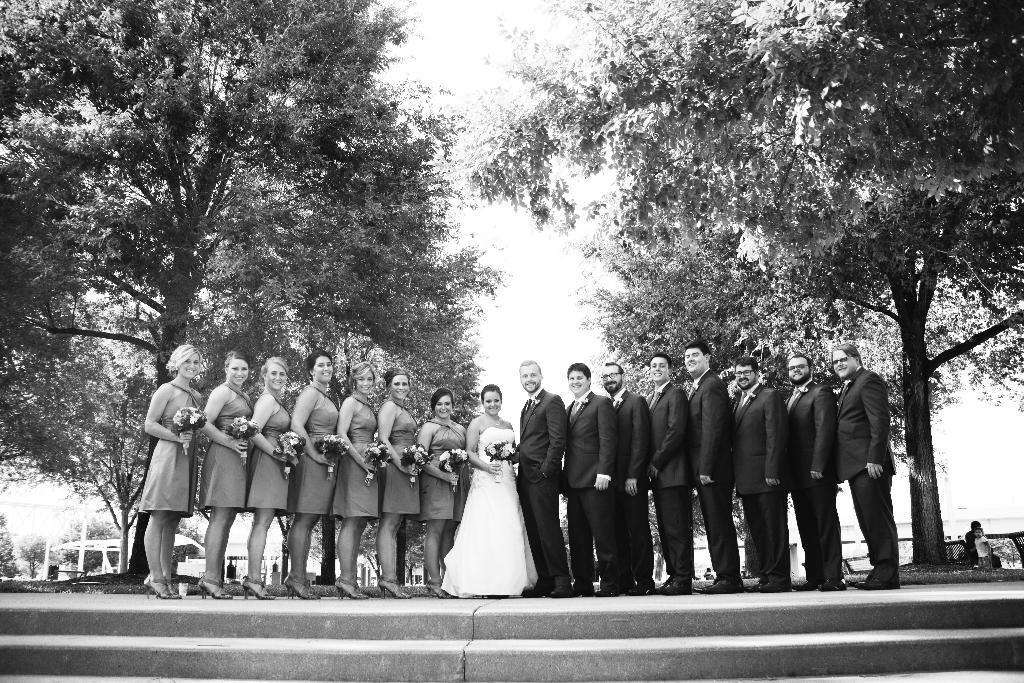In one or two sentences, can you explain what this image depicts? It is the black and white image in which there are group of people posing for the picture. There are men on the right side and women on the left side. In the middle there is a girl who is holding the flower bouquet. In the background there are trees. At the bottom there are stones. 